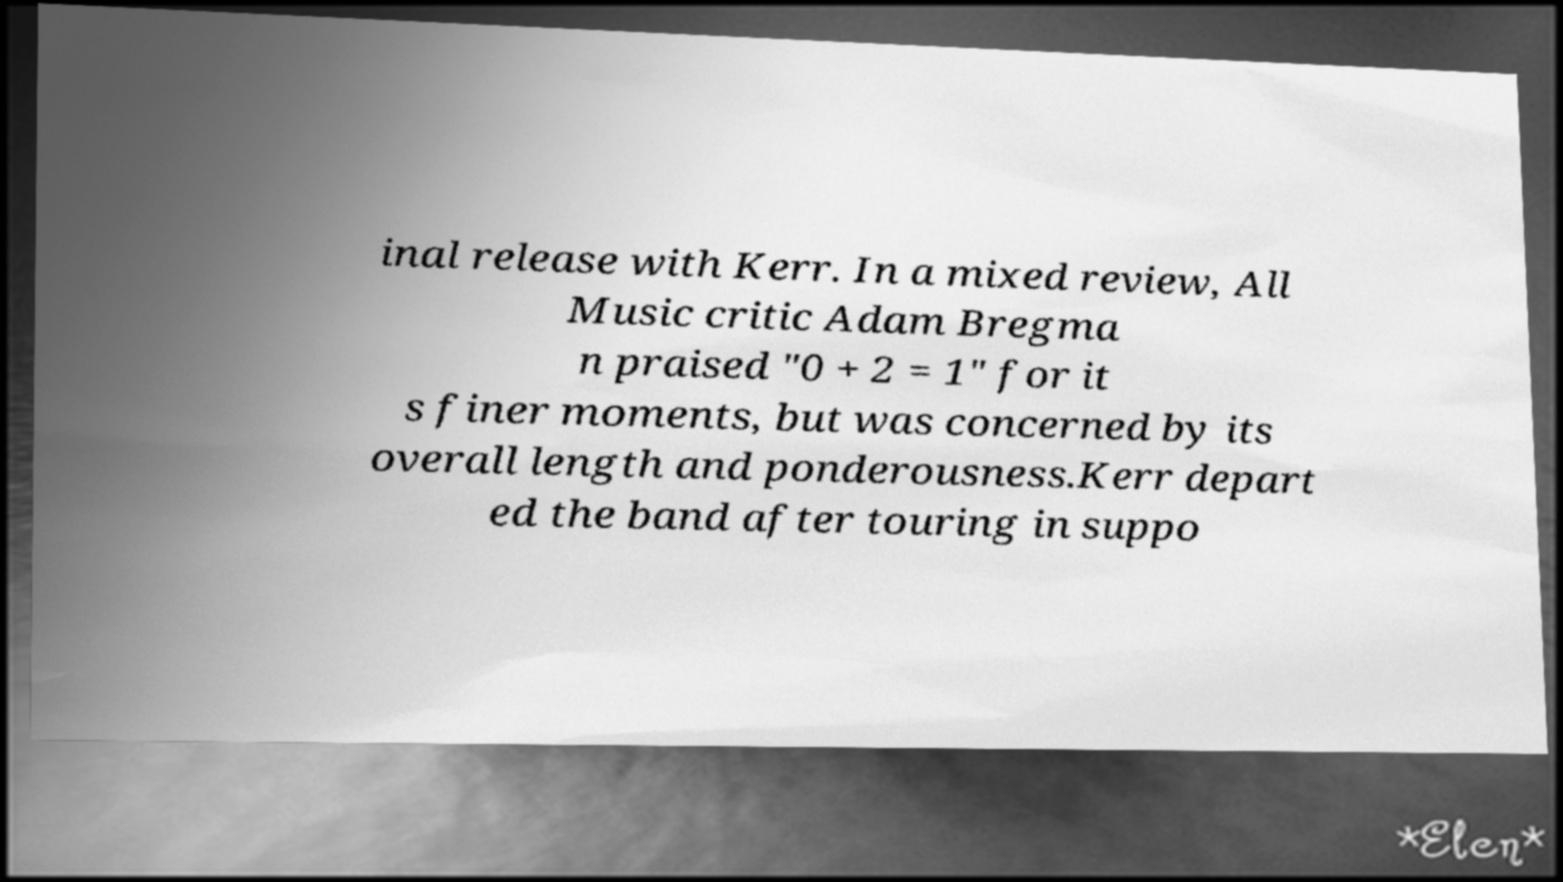I need the written content from this picture converted into text. Can you do that? inal release with Kerr. In a mixed review, All Music critic Adam Bregma n praised "0 + 2 = 1" for it s finer moments, but was concerned by its overall length and ponderousness.Kerr depart ed the band after touring in suppo 